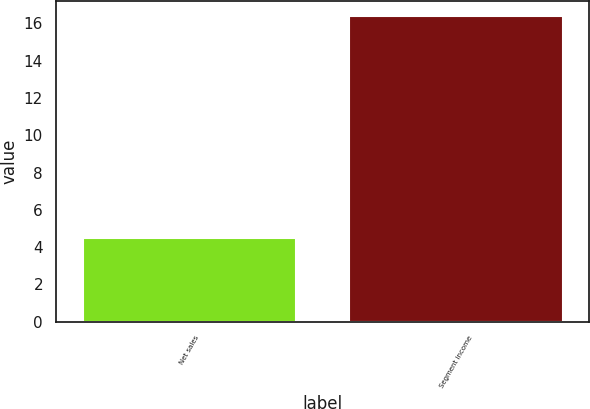Convert chart. <chart><loc_0><loc_0><loc_500><loc_500><bar_chart><fcel>Net sales<fcel>Segment income<nl><fcel>4.5<fcel>16.4<nl></chart> 